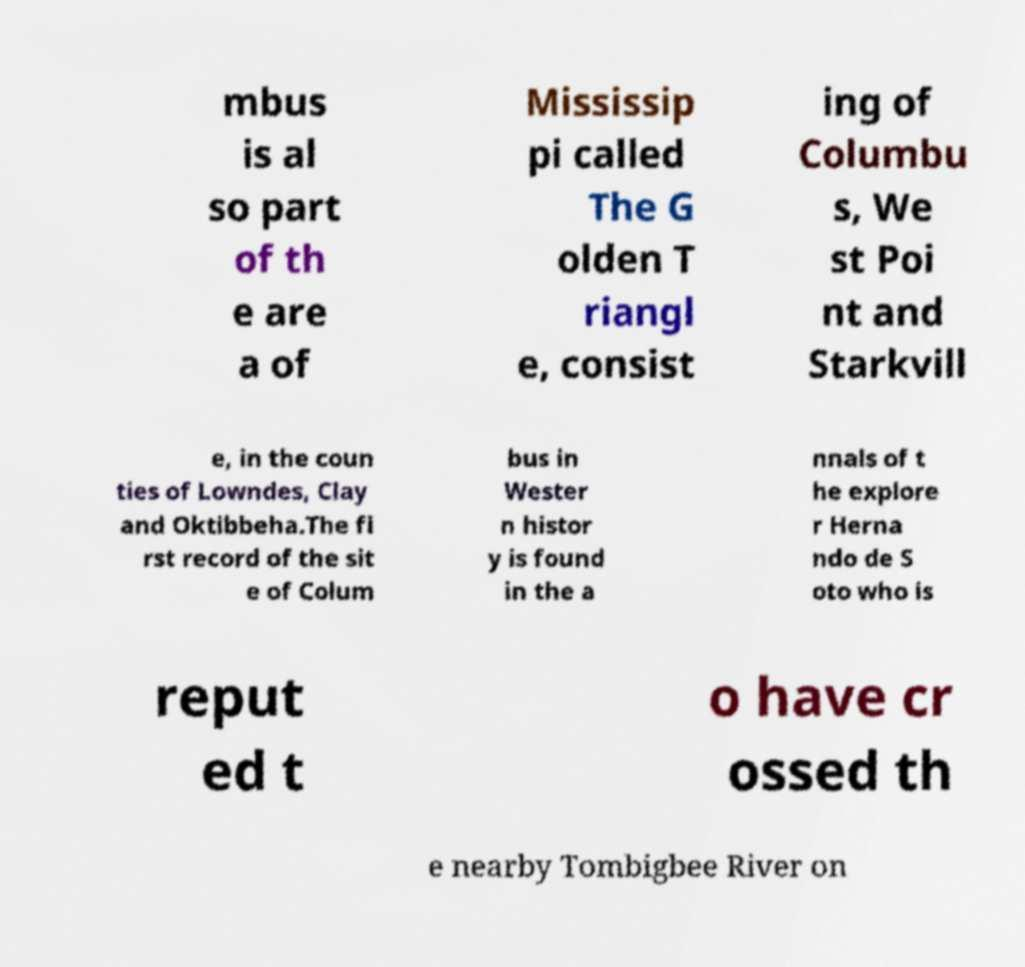Please identify and transcribe the text found in this image. mbus is al so part of th e are a of Mississip pi called The G olden T riangl e, consist ing of Columbu s, We st Poi nt and Starkvill e, in the coun ties of Lowndes, Clay and Oktibbeha.The fi rst record of the sit e of Colum bus in Wester n histor y is found in the a nnals of t he explore r Herna ndo de S oto who is reput ed t o have cr ossed th e nearby Tombigbee River on 